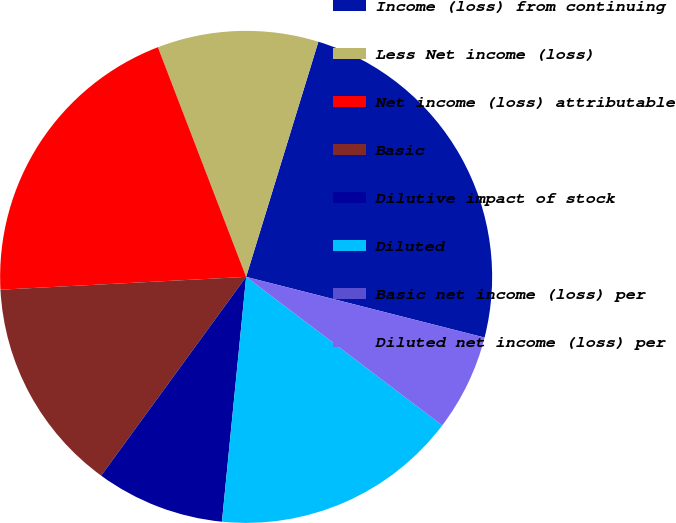<chart> <loc_0><loc_0><loc_500><loc_500><pie_chart><fcel>Income (loss) from continuing<fcel>Less Net income (loss)<fcel>Net income (loss) attributable<fcel>Basic<fcel>Dilutive impact of stock<fcel>Diluted<fcel>Basic net income (loss) per<fcel>Diluted net income (loss) per<nl><fcel>24.22%<fcel>10.58%<fcel>19.99%<fcel>14.14%<fcel>8.46%<fcel>16.25%<fcel>0.0%<fcel>6.35%<nl></chart> 